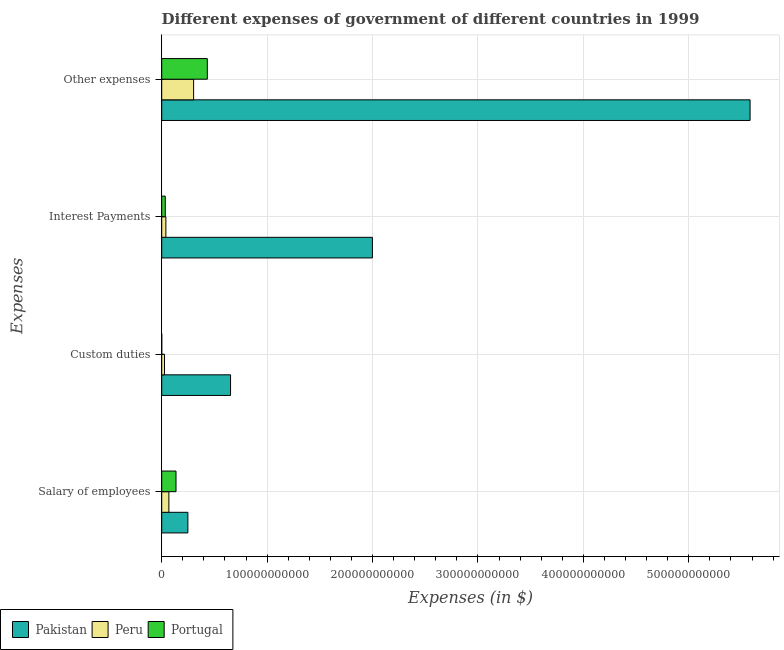How many different coloured bars are there?
Your answer should be compact. 3. Are the number of bars per tick equal to the number of legend labels?
Give a very brief answer. Yes. Are the number of bars on each tick of the Y-axis equal?
Offer a very short reply. Yes. How many bars are there on the 4th tick from the bottom?
Give a very brief answer. 3. What is the label of the 1st group of bars from the top?
Give a very brief answer. Other expenses. What is the amount spent on custom duties in Portugal?
Provide a short and direct response. 5.30e+05. Across all countries, what is the maximum amount spent on custom duties?
Provide a short and direct response. 6.53e+1. Across all countries, what is the minimum amount spent on other expenses?
Your answer should be compact. 3.03e+1. In which country was the amount spent on salary of employees maximum?
Ensure brevity in your answer.  Pakistan. In which country was the amount spent on other expenses minimum?
Offer a terse response. Peru. What is the total amount spent on salary of employees in the graph?
Offer a terse response. 4.52e+1. What is the difference between the amount spent on interest payments in Peru and that in Portugal?
Provide a short and direct response. 5.76e+08. What is the difference between the amount spent on interest payments in Pakistan and the amount spent on salary of employees in Peru?
Offer a terse response. 1.93e+11. What is the average amount spent on other expenses per country?
Provide a succinct answer. 2.11e+11. What is the difference between the amount spent on custom duties and amount spent on other expenses in Pakistan?
Make the answer very short. -4.93e+11. In how many countries, is the amount spent on interest payments greater than 560000000000 $?
Provide a succinct answer. 0. What is the ratio of the amount spent on interest payments in Pakistan to that in Peru?
Provide a short and direct response. 50.63. What is the difference between the highest and the second highest amount spent on custom duties?
Your answer should be compact. 6.26e+1. What is the difference between the highest and the lowest amount spent on salary of employees?
Your answer should be compact. 1.80e+1. In how many countries, is the amount spent on other expenses greater than the average amount spent on other expenses taken over all countries?
Offer a very short reply. 1. What does the 2nd bar from the top in Other expenses represents?
Make the answer very short. Peru. What does the 3rd bar from the bottom in Salary of employees represents?
Your answer should be very brief. Portugal. Are all the bars in the graph horizontal?
Give a very brief answer. Yes. How many countries are there in the graph?
Make the answer very short. 3. What is the difference between two consecutive major ticks on the X-axis?
Your answer should be compact. 1.00e+11. Are the values on the major ticks of X-axis written in scientific E-notation?
Your response must be concise. No. Does the graph contain any zero values?
Offer a terse response. No. Where does the legend appear in the graph?
Keep it short and to the point. Bottom left. What is the title of the graph?
Give a very brief answer. Different expenses of government of different countries in 1999. Does "Ireland" appear as one of the legend labels in the graph?
Provide a succinct answer. No. What is the label or title of the X-axis?
Your answer should be very brief. Expenses (in $). What is the label or title of the Y-axis?
Your answer should be very brief. Expenses. What is the Expenses (in $) in Pakistan in Salary of employees?
Offer a terse response. 2.48e+1. What is the Expenses (in $) of Peru in Salary of employees?
Keep it short and to the point. 6.79e+09. What is the Expenses (in $) in Portugal in Salary of employees?
Ensure brevity in your answer.  1.36e+1. What is the Expenses (in $) of Pakistan in Custom duties?
Make the answer very short. 6.53e+1. What is the Expenses (in $) in Peru in Custom duties?
Provide a succinct answer. 2.64e+09. What is the Expenses (in $) of Portugal in Custom duties?
Your answer should be compact. 5.30e+05. What is the Expenses (in $) in Pakistan in Interest Payments?
Keep it short and to the point. 2.00e+11. What is the Expenses (in $) in Peru in Interest Payments?
Offer a very short reply. 3.95e+09. What is the Expenses (in $) in Portugal in Interest Payments?
Your answer should be compact. 3.37e+09. What is the Expenses (in $) in Pakistan in Other expenses?
Ensure brevity in your answer.  5.58e+11. What is the Expenses (in $) of Peru in Other expenses?
Give a very brief answer. 3.03e+1. What is the Expenses (in $) of Portugal in Other expenses?
Your response must be concise. 4.33e+1. Across all Expenses, what is the maximum Expenses (in $) in Pakistan?
Offer a terse response. 5.58e+11. Across all Expenses, what is the maximum Expenses (in $) in Peru?
Your response must be concise. 3.03e+1. Across all Expenses, what is the maximum Expenses (in $) of Portugal?
Keep it short and to the point. 4.33e+1. Across all Expenses, what is the minimum Expenses (in $) in Pakistan?
Offer a very short reply. 2.48e+1. Across all Expenses, what is the minimum Expenses (in $) in Peru?
Provide a short and direct response. 2.64e+09. Across all Expenses, what is the minimum Expenses (in $) of Portugal?
Offer a very short reply. 5.30e+05. What is the total Expenses (in $) of Pakistan in the graph?
Provide a succinct answer. 8.48e+11. What is the total Expenses (in $) of Peru in the graph?
Keep it short and to the point. 4.36e+1. What is the total Expenses (in $) in Portugal in the graph?
Offer a very short reply. 6.02e+1. What is the difference between the Expenses (in $) of Pakistan in Salary of employees and that in Custom duties?
Provide a short and direct response. -4.05e+1. What is the difference between the Expenses (in $) of Peru in Salary of employees and that in Custom duties?
Give a very brief answer. 4.15e+09. What is the difference between the Expenses (in $) in Portugal in Salary of employees and that in Custom duties?
Ensure brevity in your answer.  1.36e+1. What is the difference between the Expenses (in $) in Pakistan in Salary of employees and that in Interest Payments?
Provide a succinct answer. -1.75e+11. What is the difference between the Expenses (in $) in Peru in Salary of employees and that in Interest Payments?
Your answer should be compact. 2.85e+09. What is the difference between the Expenses (in $) in Portugal in Salary of employees and that in Interest Payments?
Give a very brief answer. 1.02e+1. What is the difference between the Expenses (in $) in Pakistan in Salary of employees and that in Other expenses?
Your answer should be very brief. -5.33e+11. What is the difference between the Expenses (in $) in Peru in Salary of employees and that in Other expenses?
Keep it short and to the point. -2.35e+1. What is the difference between the Expenses (in $) in Portugal in Salary of employees and that in Other expenses?
Ensure brevity in your answer.  -2.97e+1. What is the difference between the Expenses (in $) of Pakistan in Custom duties and that in Interest Payments?
Ensure brevity in your answer.  -1.35e+11. What is the difference between the Expenses (in $) in Peru in Custom duties and that in Interest Payments?
Your answer should be very brief. -1.31e+09. What is the difference between the Expenses (in $) of Portugal in Custom duties and that in Interest Payments?
Ensure brevity in your answer.  -3.37e+09. What is the difference between the Expenses (in $) in Pakistan in Custom duties and that in Other expenses?
Provide a short and direct response. -4.93e+11. What is the difference between the Expenses (in $) of Peru in Custom duties and that in Other expenses?
Offer a terse response. -2.76e+1. What is the difference between the Expenses (in $) in Portugal in Custom duties and that in Other expenses?
Make the answer very short. -4.33e+1. What is the difference between the Expenses (in $) in Pakistan in Interest Payments and that in Other expenses?
Your response must be concise. -3.58e+11. What is the difference between the Expenses (in $) of Peru in Interest Payments and that in Other expenses?
Ensure brevity in your answer.  -2.63e+1. What is the difference between the Expenses (in $) of Portugal in Interest Payments and that in Other expenses?
Provide a succinct answer. -3.99e+1. What is the difference between the Expenses (in $) in Pakistan in Salary of employees and the Expenses (in $) in Peru in Custom duties?
Your answer should be compact. 2.22e+1. What is the difference between the Expenses (in $) in Pakistan in Salary of employees and the Expenses (in $) in Portugal in Custom duties?
Provide a succinct answer. 2.48e+1. What is the difference between the Expenses (in $) of Peru in Salary of employees and the Expenses (in $) of Portugal in Custom duties?
Offer a terse response. 6.79e+09. What is the difference between the Expenses (in $) of Pakistan in Salary of employees and the Expenses (in $) of Peru in Interest Payments?
Make the answer very short. 2.09e+1. What is the difference between the Expenses (in $) in Pakistan in Salary of employees and the Expenses (in $) in Portugal in Interest Payments?
Provide a succinct answer. 2.14e+1. What is the difference between the Expenses (in $) in Peru in Salary of employees and the Expenses (in $) in Portugal in Interest Payments?
Your response must be concise. 3.42e+09. What is the difference between the Expenses (in $) of Pakistan in Salary of employees and the Expenses (in $) of Peru in Other expenses?
Ensure brevity in your answer.  -5.45e+09. What is the difference between the Expenses (in $) of Pakistan in Salary of employees and the Expenses (in $) of Portugal in Other expenses?
Your answer should be compact. -1.85e+1. What is the difference between the Expenses (in $) in Peru in Salary of employees and the Expenses (in $) in Portugal in Other expenses?
Your answer should be compact. -3.65e+1. What is the difference between the Expenses (in $) in Pakistan in Custom duties and the Expenses (in $) in Peru in Interest Payments?
Provide a short and direct response. 6.13e+1. What is the difference between the Expenses (in $) in Pakistan in Custom duties and the Expenses (in $) in Portugal in Interest Payments?
Make the answer very short. 6.19e+1. What is the difference between the Expenses (in $) in Peru in Custom duties and the Expenses (in $) in Portugal in Interest Payments?
Make the answer very short. -7.29e+08. What is the difference between the Expenses (in $) of Pakistan in Custom duties and the Expenses (in $) of Peru in Other expenses?
Give a very brief answer. 3.50e+1. What is the difference between the Expenses (in $) in Pakistan in Custom duties and the Expenses (in $) in Portugal in Other expenses?
Your answer should be very brief. 2.20e+1. What is the difference between the Expenses (in $) in Peru in Custom duties and the Expenses (in $) in Portugal in Other expenses?
Offer a very short reply. -4.06e+1. What is the difference between the Expenses (in $) in Pakistan in Interest Payments and the Expenses (in $) in Peru in Other expenses?
Provide a short and direct response. 1.70e+11. What is the difference between the Expenses (in $) in Pakistan in Interest Payments and the Expenses (in $) in Portugal in Other expenses?
Provide a succinct answer. 1.57e+11. What is the difference between the Expenses (in $) in Peru in Interest Payments and the Expenses (in $) in Portugal in Other expenses?
Provide a succinct answer. -3.93e+1. What is the average Expenses (in $) of Pakistan per Expenses?
Your answer should be compact. 2.12e+11. What is the average Expenses (in $) of Peru per Expenses?
Offer a terse response. 1.09e+1. What is the average Expenses (in $) of Portugal per Expenses?
Offer a very short reply. 1.51e+1. What is the difference between the Expenses (in $) in Pakistan and Expenses (in $) in Peru in Salary of employees?
Provide a succinct answer. 1.80e+1. What is the difference between the Expenses (in $) of Pakistan and Expenses (in $) of Portugal in Salary of employees?
Provide a short and direct response. 1.12e+1. What is the difference between the Expenses (in $) of Peru and Expenses (in $) of Portugal in Salary of employees?
Make the answer very short. -6.78e+09. What is the difference between the Expenses (in $) in Pakistan and Expenses (in $) in Peru in Custom duties?
Offer a terse response. 6.26e+1. What is the difference between the Expenses (in $) in Pakistan and Expenses (in $) in Portugal in Custom duties?
Offer a terse response. 6.53e+1. What is the difference between the Expenses (in $) in Peru and Expenses (in $) in Portugal in Custom duties?
Provide a succinct answer. 2.64e+09. What is the difference between the Expenses (in $) of Pakistan and Expenses (in $) of Peru in Interest Payments?
Provide a succinct answer. 1.96e+11. What is the difference between the Expenses (in $) of Pakistan and Expenses (in $) of Portugal in Interest Payments?
Make the answer very short. 1.96e+11. What is the difference between the Expenses (in $) in Peru and Expenses (in $) in Portugal in Interest Payments?
Provide a succinct answer. 5.76e+08. What is the difference between the Expenses (in $) of Pakistan and Expenses (in $) of Peru in Other expenses?
Make the answer very short. 5.28e+11. What is the difference between the Expenses (in $) in Pakistan and Expenses (in $) in Portugal in Other expenses?
Keep it short and to the point. 5.15e+11. What is the difference between the Expenses (in $) of Peru and Expenses (in $) of Portugal in Other expenses?
Your answer should be very brief. -1.30e+1. What is the ratio of the Expenses (in $) in Pakistan in Salary of employees to that in Custom duties?
Offer a very short reply. 0.38. What is the ratio of the Expenses (in $) in Peru in Salary of employees to that in Custom duties?
Make the answer very short. 2.57. What is the ratio of the Expenses (in $) of Portugal in Salary of employees to that in Custom duties?
Your response must be concise. 2.56e+04. What is the ratio of the Expenses (in $) of Pakistan in Salary of employees to that in Interest Payments?
Ensure brevity in your answer.  0.12. What is the ratio of the Expenses (in $) in Peru in Salary of employees to that in Interest Payments?
Give a very brief answer. 1.72. What is the ratio of the Expenses (in $) in Portugal in Salary of employees to that in Interest Payments?
Keep it short and to the point. 4.03. What is the ratio of the Expenses (in $) of Pakistan in Salary of employees to that in Other expenses?
Give a very brief answer. 0.04. What is the ratio of the Expenses (in $) in Peru in Salary of employees to that in Other expenses?
Provide a short and direct response. 0.22. What is the ratio of the Expenses (in $) in Portugal in Salary of employees to that in Other expenses?
Provide a succinct answer. 0.31. What is the ratio of the Expenses (in $) in Pakistan in Custom duties to that in Interest Payments?
Keep it short and to the point. 0.33. What is the ratio of the Expenses (in $) of Peru in Custom duties to that in Interest Payments?
Offer a terse response. 0.67. What is the ratio of the Expenses (in $) of Portugal in Custom duties to that in Interest Payments?
Provide a short and direct response. 0. What is the ratio of the Expenses (in $) in Pakistan in Custom duties to that in Other expenses?
Provide a short and direct response. 0.12. What is the ratio of the Expenses (in $) in Peru in Custom duties to that in Other expenses?
Keep it short and to the point. 0.09. What is the ratio of the Expenses (in $) in Portugal in Custom duties to that in Other expenses?
Keep it short and to the point. 0. What is the ratio of the Expenses (in $) in Pakistan in Interest Payments to that in Other expenses?
Offer a very short reply. 0.36. What is the ratio of the Expenses (in $) of Peru in Interest Payments to that in Other expenses?
Keep it short and to the point. 0.13. What is the ratio of the Expenses (in $) of Portugal in Interest Payments to that in Other expenses?
Keep it short and to the point. 0.08. What is the difference between the highest and the second highest Expenses (in $) in Pakistan?
Give a very brief answer. 3.58e+11. What is the difference between the highest and the second highest Expenses (in $) of Peru?
Your response must be concise. 2.35e+1. What is the difference between the highest and the second highest Expenses (in $) of Portugal?
Offer a terse response. 2.97e+1. What is the difference between the highest and the lowest Expenses (in $) in Pakistan?
Keep it short and to the point. 5.33e+11. What is the difference between the highest and the lowest Expenses (in $) of Peru?
Provide a succinct answer. 2.76e+1. What is the difference between the highest and the lowest Expenses (in $) of Portugal?
Give a very brief answer. 4.33e+1. 